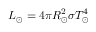<formula> <loc_0><loc_0><loc_500><loc_500>L _ { \odot } = 4 \pi R _ { \odot } ^ { 2 } \sigma T _ { \odot } ^ { 4 }</formula> 